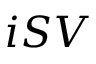<formula> <loc_0><loc_0><loc_500><loc_500>i S V</formula> 